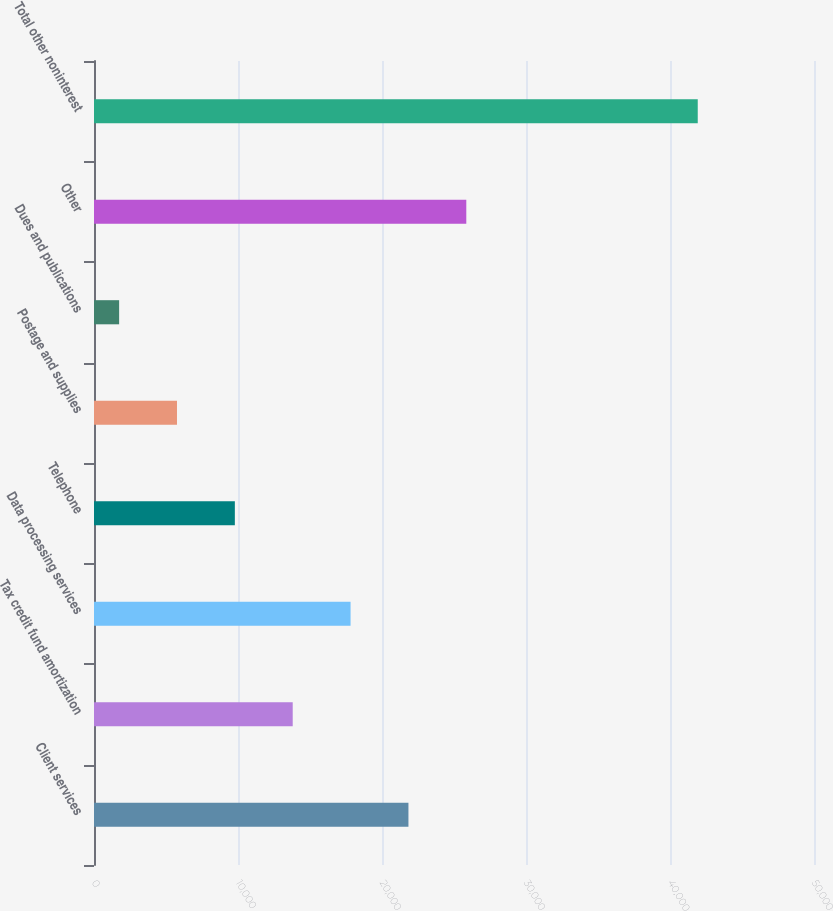Convert chart to OTSL. <chart><loc_0><loc_0><loc_500><loc_500><bar_chart><fcel>Client services<fcel>Tax credit fund amortization<fcel>Data processing services<fcel>Telephone<fcel>Postage and supplies<fcel>Dues and publications<fcel>Other<fcel>Total other noninterest<nl><fcel>21836<fcel>13799.6<fcel>17817.8<fcel>9781.4<fcel>5763.2<fcel>1745<fcel>25854.2<fcel>41927<nl></chart> 